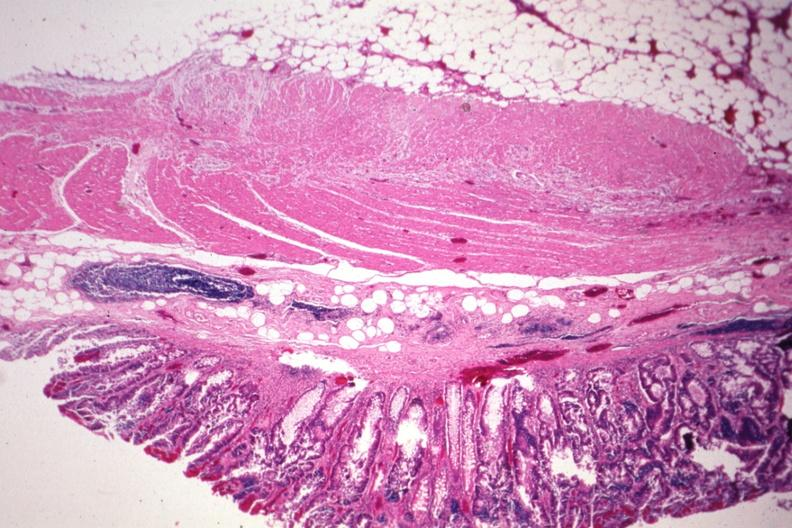s carcinoma superficial spreading present?
Answer the question using a single word or phrase. Yes 